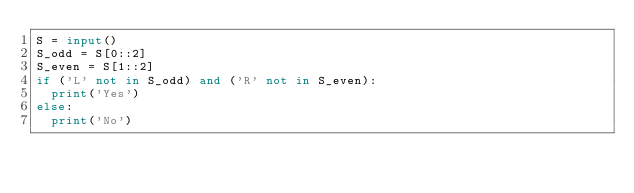Convert code to text. <code><loc_0><loc_0><loc_500><loc_500><_Python_>S = input()
S_odd = S[0::2]
S_even = S[1::2]
if ('L' not in S_odd) and ('R' not in S_even):
  print('Yes')
else:
  print('No')</code> 